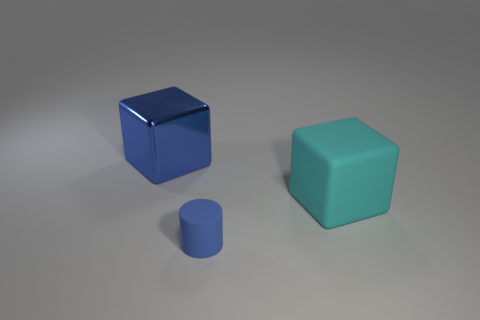Add 1 big blue shiny cubes. How many objects exist? 4 Subtract all cylinders. How many objects are left? 2 Add 2 blue cylinders. How many blue cylinders are left? 3 Add 2 blue cylinders. How many blue cylinders exist? 3 Subtract 0 brown cylinders. How many objects are left? 3 Subtract all small cylinders. Subtract all blue metal objects. How many objects are left? 1 